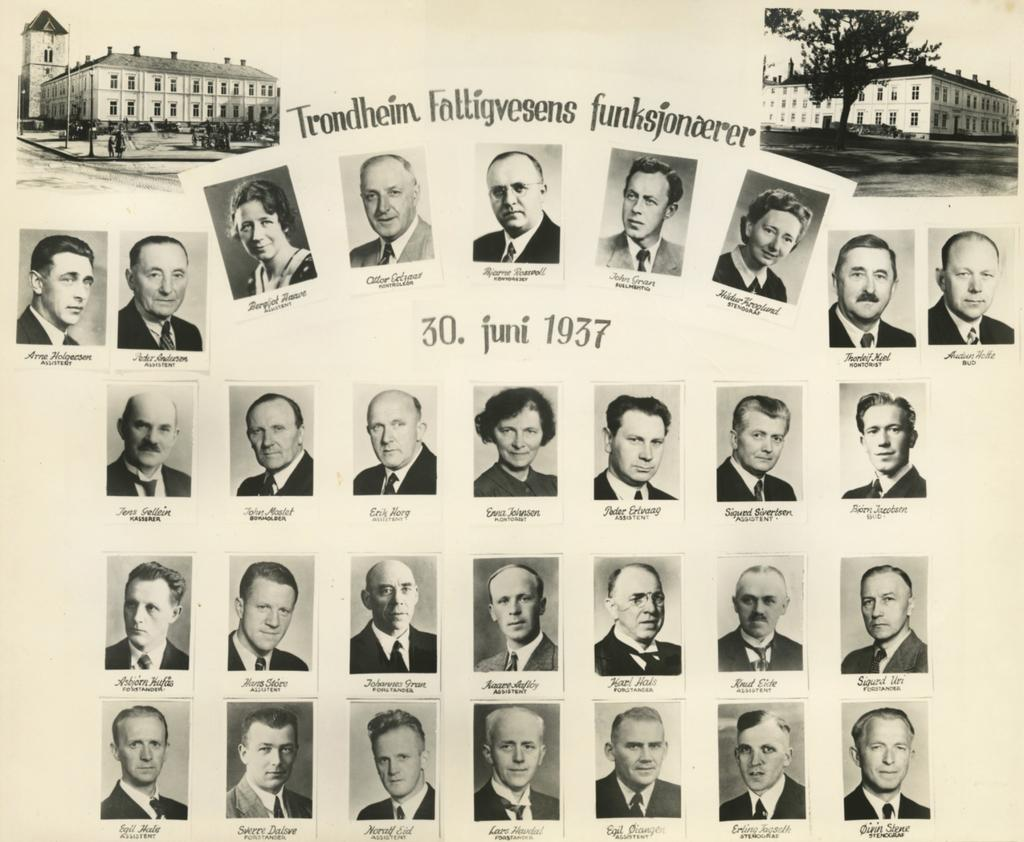What is present in the image? There is a paper in the image. What can be found on the paper? The paper contains images of people. What type of spring can be seen in the image? There is no spring present in the image; it only contains images of people on a paper. 